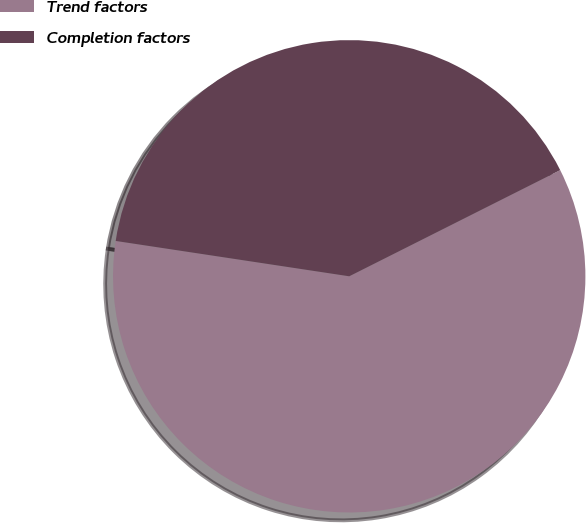Convert chart to OTSL. <chart><loc_0><loc_0><loc_500><loc_500><pie_chart><fcel>Trend factors<fcel>Completion factors<nl><fcel>59.81%<fcel>40.19%<nl></chart> 